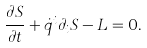Convert formula to latex. <formula><loc_0><loc_0><loc_500><loc_500>\frac { \partial S } { \partial t } + \dot { q } ^ { i } \partial _ { i } S - L = 0 .</formula> 